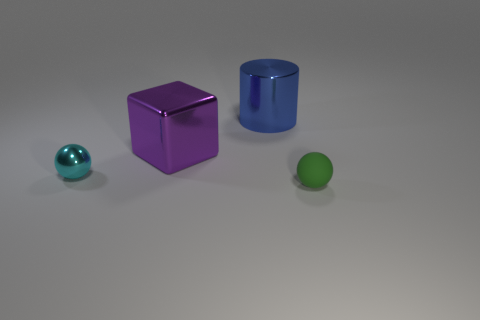There is a purple block that is the same size as the blue cylinder; what material is it?
Give a very brief answer. Metal. Is the size of the object that is in front of the small cyan metallic thing the same as the metallic object that is behind the large purple block?
Your answer should be very brief. No. Is there a block made of the same material as the tiny cyan ball?
Offer a terse response. Yes. How many things are either objects left of the matte thing or tiny spheres?
Provide a short and direct response. 4. Is the material of the sphere behind the green rubber thing the same as the small green object?
Provide a short and direct response. No. Does the big blue thing have the same shape as the small green thing?
Ensure brevity in your answer.  No. There is a ball that is to the left of the green rubber thing; how many tiny cyan things are left of it?
Offer a very short reply. 0. There is a cyan thing that is the same shape as the small green matte object; what material is it?
Keep it short and to the point. Metal. There is a large object to the left of the blue shiny cylinder; is it the same color as the cylinder?
Offer a very short reply. No. Does the large cube have the same material as the thing on the right side of the metal cylinder?
Offer a terse response. No. 